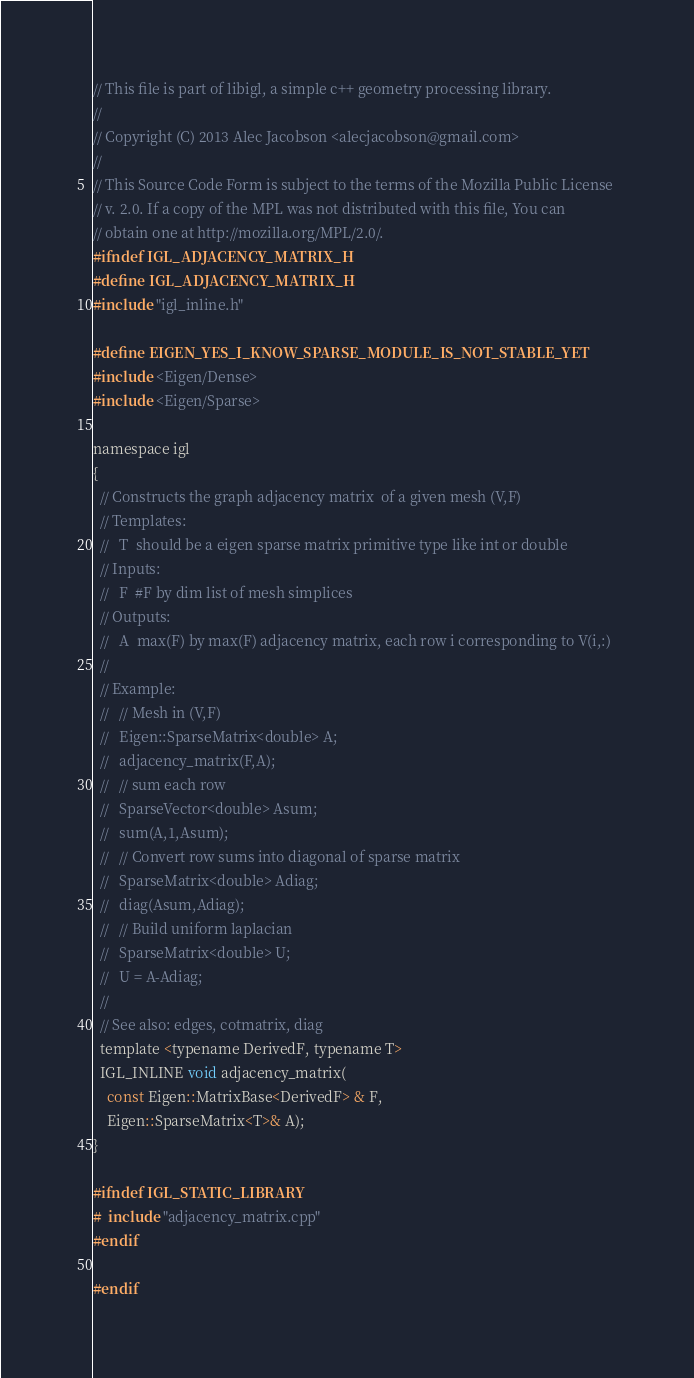<code> <loc_0><loc_0><loc_500><loc_500><_C_>// This file is part of libigl, a simple c++ geometry processing library.
// 
// Copyright (C) 2013 Alec Jacobson <alecjacobson@gmail.com>
// 
// This Source Code Form is subject to the terms of the Mozilla Public License 
// v. 2.0. If a copy of the MPL was not distributed with this file, You can 
// obtain one at http://mozilla.org/MPL/2.0/.
#ifndef IGL_ADJACENCY_MATRIX_H
#define IGL_ADJACENCY_MATRIX_H
#include "igl_inline.h"

#define EIGEN_YES_I_KNOW_SPARSE_MODULE_IS_NOT_STABLE_YET
#include <Eigen/Dense>
#include <Eigen/Sparse>

namespace igl 
{
  // Constructs the graph adjacency matrix  of a given mesh (V,F)
  // Templates:
  //   T  should be a eigen sparse matrix primitive type like int or double
  // Inputs:
  //   F  #F by dim list of mesh simplices
  // Outputs: 
  //   A  max(F) by max(F) adjacency matrix, each row i corresponding to V(i,:)
  //
  // Example:
  //   // Mesh in (V,F)
  //   Eigen::SparseMatrix<double> A;
  //   adjacency_matrix(F,A);
  //   // sum each row 
  //   SparseVector<double> Asum;
  //   sum(A,1,Asum);
  //   // Convert row sums into diagonal of sparse matrix
  //   SparseMatrix<double> Adiag;
  //   diag(Asum,Adiag);
  //   // Build uniform laplacian
  //   SparseMatrix<double> U;
  //   U = A-Adiag;
  //
  // See also: edges, cotmatrix, diag
  template <typename DerivedF, typename T>
  IGL_INLINE void adjacency_matrix(
    const Eigen::MatrixBase<DerivedF> & F, 
    Eigen::SparseMatrix<T>& A);
}

#ifndef IGL_STATIC_LIBRARY
#  include "adjacency_matrix.cpp"
#endif

#endif
</code> 